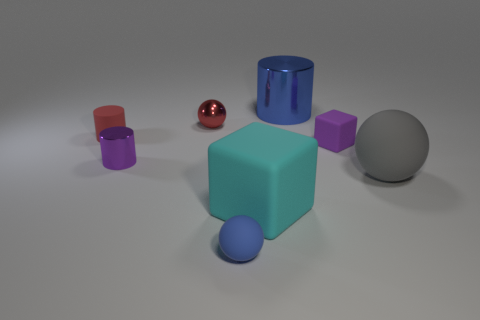There is a thing that is the same color as the tiny metal ball; what is its material?
Provide a succinct answer. Rubber. The large matte object on the right side of the purple rubber cube has what shape?
Offer a terse response. Sphere. How many red cylinders are the same size as the blue sphere?
Give a very brief answer. 1. What size is the metal sphere?
Provide a succinct answer. Small. There is a red cylinder; how many red objects are behind it?
Keep it short and to the point. 1. There is a red object that is the same material as the blue sphere; what is its shape?
Provide a succinct answer. Cylinder. Are there fewer cylinders that are right of the large cyan object than blue balls on the left side of the tiny red ball?
Provide a succinct answer. No. Is the number of big cylinders greater than the number of tiny red cubes?
Give a very brief answer. Yes. What material is the large block?
Your answer should be very brief. Rubber. The big thing that is behind the red shiny object is what color?
Your answer should be very brief. Blue. 